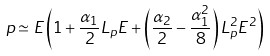Convert formula to latex. <formula><loc_0><loc_0><loc_500><loc_500>p \simeq E \left ( 1 + \frac { \alpha _ { 1 } } { 2 } L _ { p } E + \left ( \frac { \alpha _ { 2 } } { 2 } - \frac { \alpha _ { 1 } ^ { 2 } } { 8 } \right ) L _ { p } ^ { 2 } E ^ { 2 } \right )</formula> 